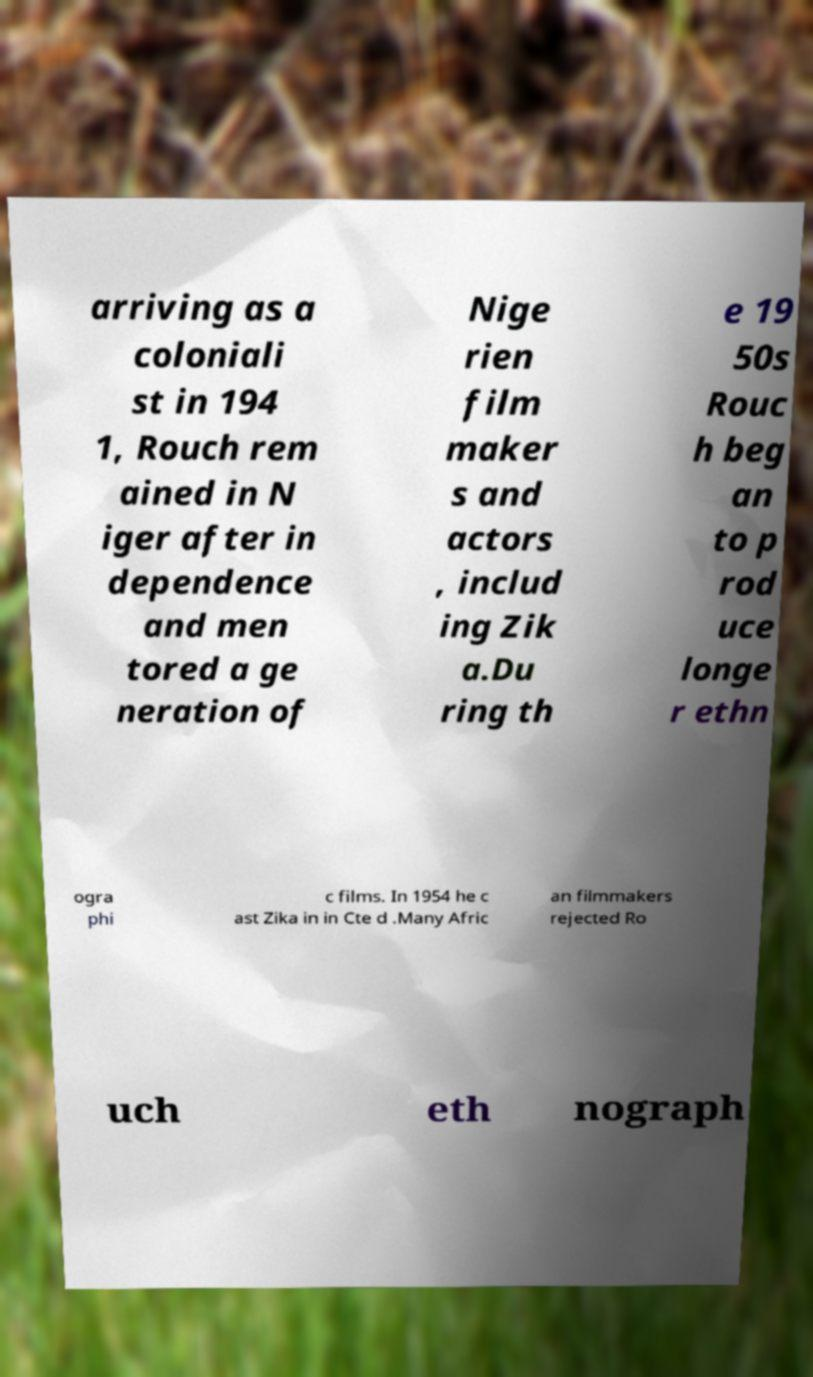There's text embedded in this image that I need extracted. Can you transcribe it verbatim? arriving as a coloniali st in 194 1, Rouch rem ained in N iger after in dependence and men tored a ge neration of Nige rien film maker s and actors , includ ing Zik a.Du ring th e 19 50s Rouc h beg an to p rod uce longe r ethn ogra phi c films. In 1954 he c ast Zika in in Cte d .Many Afric an filmmakers rejected Ro uch eth nograph 